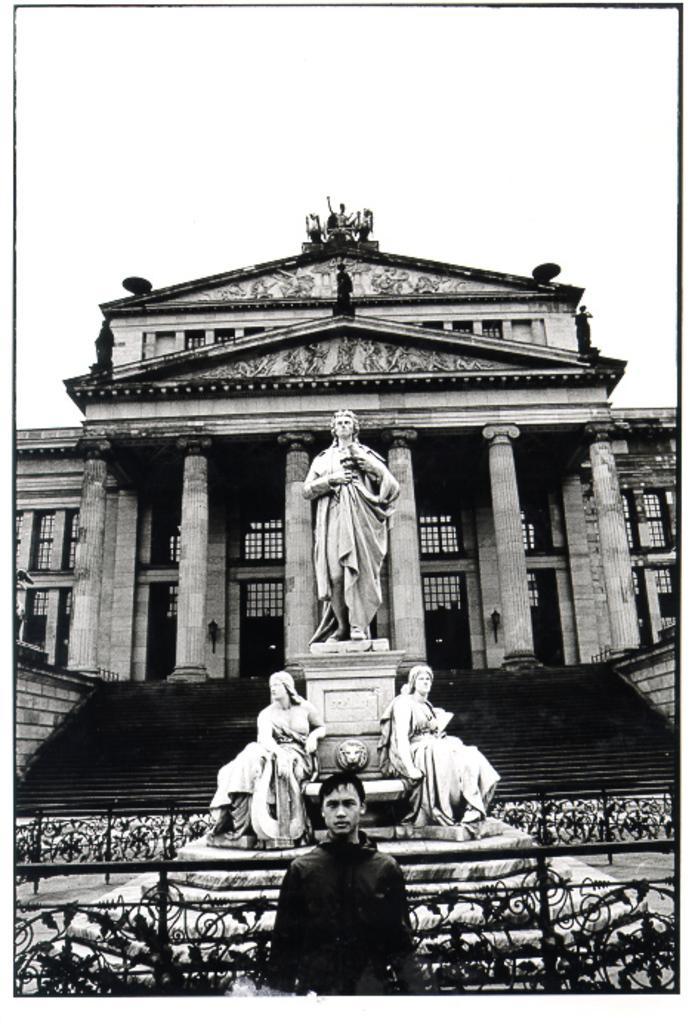Could you give a brief overview of what you see in this image? This is a black and white image. In this image we can see there is a building, in front of the building there is a statue of three persons, beside the statue there are stairs. In the foreground of the image there is a person stand. In the background there is a sky. 